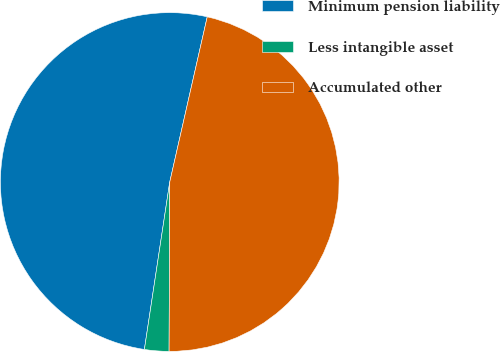<chart> <loc_0><loc_0><loc_500><loc_500><pie_chart><fcel>Minimum pension liability<fcel>Less intangible asset<fcel>Accumulated other<nl><fcel>51.16%<fcel>2.33%<fcel>46.51%<nl></chart> 